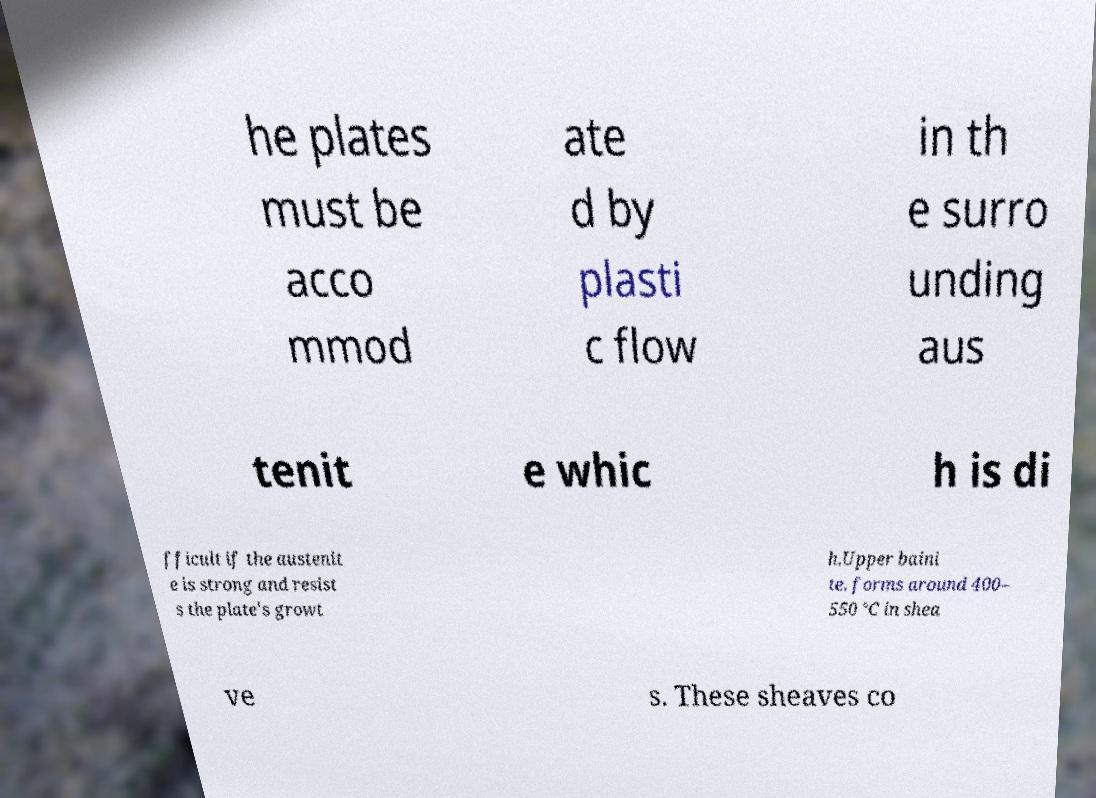What messages or text are displayed in this image? I need them in a readable, typed format. he plates must be acco mmod ate d by plasti c flow in th e surro unding aus tenit e whic h is di fficult if the austenit e is strong and resist s the plate's growt h.Upper baini te. forms around 400– 550 °C in shea ve s. These sheaves co 